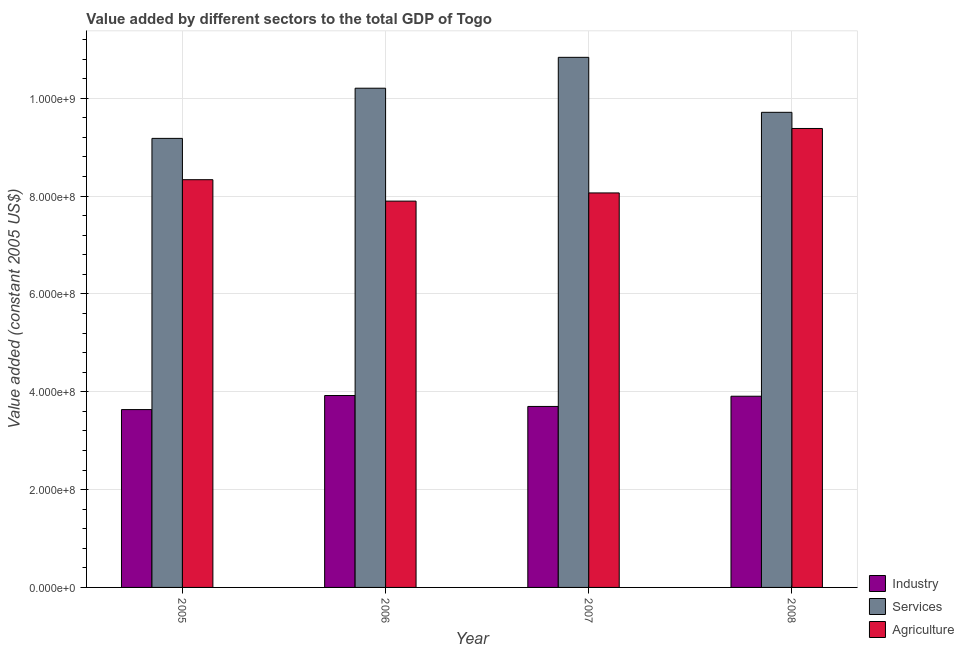How many groups of bars are there?
Offer a very short reply. 4. Are the number of bars on each tick of the X-axis equal?
Keep it short and to the point. Yes. How many bars are there on the 4th tick from the left?
Ensure brevity in your answer.  3. What is the label of the 2nd group of bars from the left?
Keep it short and to the point. 2006. What is the value added by agricultural sector in 2006?
Provide a short and direct response. 7.90e+08. Across all years, what is the maximum value added by agricultural sector?
Keep it short and to the point. 9.38e+08. Across all years, what is the minimum value added by services?
Make the answer very short. 9.18e+08. In which year was the value added by services minimum?
Ensure brevity in your answer.  2005. What is the total value added by services in the graph?
Your response must be concise. 3.99e+09. What is the difference between the value added by agricultural sector in 2005 and that in 2006?
Your answer should be very brief. 4.38e+07. What is the difference between the value added by agricultural sector in 2007 and the value added by industrial sector in 2006?
Your answer should be very brief. 1.67e+07. What is the average value added by agricultural sector per year?
Provide a succinct answer. 8.42e+08. In how many years, is the value added by services greater than 760000000 US$?
Keep it short and to the point. 4. What is the ratio of the value added by industrial sector in 2005 to that in 2007?
Your answer should be compact. 0.98. What is the difference between the highest and the second highest value added by services?
Offer a very short reply. 6.31e+07. What is the difference between the highest and the lowest value added by agricultural sector?
Make the answer very short. 1.49e+08. What does the 1st bar from the left in 2008 represents?
Offer a terse response. Industry. What does the 2nd bar from the right in 2006 represents?
Provide a short and direct response. Services. Is it the case that in every year, the sum of the value added by industrial sector and value added by services is greater than the value added by agricultural sector?
Make the answer very short. Yes. What is the difference between two consecutive major ticks on the Y-axis?
Your answer should be compact. 2.00e+08. Are the values on the major ticks of Y-axis written in scientific E-notation?
Offer a terse response. Yes. Where does the legend appear in the graph?
Ensure brevity in your answer.  Bottom right. What is the title of the graph?
Keep it short and to the point. Value added by different sectors to the total GDP of Togo. What is the label or title of the X-axis?
Offer a terse response. Year. What is the label or title of the Y-axis?
Give a very brief answer. Value added (constant 2005 US$). What is the Value added (constant 2005 US$) in Industry in 2005?
Make the answer very short. 3.64e+08. What is the Value added (constant 2005 US$) in Services in 2005?
Provide a short and direct response. 9.18e+08. What is the Value added (constant 2005 US$) of Agriculture in 2005?
Your answer should be very brief. 8.34e+08. What is the Value added (constant 2005 US$) in Industry in 2006?
Your answer should be compact. 3.92e+08. What is the Value added (constant 2005 US$) in Services in 2006?
Ensure brevity in your answer.  1.02e+09. What is the Value added (constant 2005 US$) in Agriculture in 2006?
Make the answer very short. 7.90e+08. What is the Value added (constant 2005 US$) in Industry in 2007?
Offer a very short reply. 3.70e+08. What is the Value added (constant 2005 US$) in Services in 2007?
Give a very brief answer. 1.08e+09. What is the Value added (constant 2005 US$) in Agriculture in 2007?
Keep it short and to the point. 8.06e+08. What is the Value added (constant 2005 US$) in Industry in 2008?
Make the answer very short. 3.91e+08. What is the Value added (constant 2005 US$) in Services in 2008?
Your response must be concise. 9.71e+08. What is the Value added (constant 2005 US$) in Agriculture in 2008?
Offer a terse response. 9.38e+08. Across all years, what is the maximum Value added (constant 2005 US$) of Industry?
Offer a very short reply. 3.92e+08. Across all years, what is the maximum Value added (constant 2005 US$) in Services?
Make the answer very short. 1.08e+09. Across all years, what is the maximum Value added (constant 2005 US$) in Agriculture?
Offer a very short reply. 9.38e+08. Across all years, what is the minimum Value added (constant 2005 US$) of Industry?
Ensure brevity in your answer.  3.64e+08. Across all years, what is the minimum Value added (constant 2005 US$) of Services?
Your response must be concise. 9.18e+08. Across all years, what is the minimum Value added (constant 2005 US$) in Agriculture?
Provide a succinct answer. 7.90e+08. What is the total Value added (constant 2005 US$) in Industry in the graph?
Keep it short and to the point. 1.52e+09. What is the total Value added (constant 2005 US$) in Services in the graph?
Make the answer very short. 3.99e+09. What is the total Value added (constant 2005 US$) of Agriculture in the graph?
Your response must be concise. 3.37e+09. What is the difference between the Value added (constant 2005 US$) of Industry in 2005 and that in 2006?
Give a very brief answer. -2.87e+07. What is the difference between the Value added (constant 2005 US$) in Services in 2005 and that in 2006?
Give a very brief answer. -1.03e+08. What is the difference between the Value added (constant 2005 US$) in Agriculture in 2005 and that in 2006?
Ensure brevity in your answer.  4.38e+07. What is the difference between the Value added (constant 2005 US$) in Industry in 2005 and that in 2007?
Your answer should be compact. -6.42e+06. What is the difference between the Value added (constant 2005 US$) in Services in 2005 and that in 2007?
Your response must be concise. -1.66e+08. What is the difference between the Value added (constant 2005 US$) of Agriculture in 2005 and that in 2007?
Offer a terse response. 2.71e+07. What is the difference between the Value added (constant 2005 US$) in Industry in 2005 and that in 2008?
Your answer should be compact. -2.73e+07. What is the difference between the Value added (constant 2005 US$) in Services in 2005 and that in 2008?
Your response must be concise. -5.33e+07. What is the difference between the Value added (constant 2005 US$) in Agriculture in 2005 and that in 2008?
Your answer should be very brief. -1.05e+08. What is the difference between the Value added (constant 2005 US$) of Industry in 2006 and that in 2007?
Your answer should be very brief. 2.23e+07. What is the difference between the Value added (constant 2005 US$) in Services in 2006 and that in 2007?
Your answer should be compact. -6.31e+07. What is the difference between the Value added (constant 2005 US$) of Agriculture in 2006 and that in 2007?
Give a very brief answer. -1.67e+07. What is the difference between the Value added (constant 2005 US$) of Industry in 2006 and that in 2008?
Offer a very short reply. 1.43e+06. What is the difference between the Value added (constant 2005 US$) in Services in 2006 and that in 2008?
Provide a succinct answer. 4.93e+07. What is the difference between the Value added (constant 2005 US$) in Agriculture in 2006 and that in 2008?
Your answer should be very brief. -1.49e+08. What is the difference between the Value added (constant 2005 US$) of Industry in 2007 and that in 2008?
Give a very brief answer. -2.09e+07. What is the difference between the Value added (constant 2005 US$) in Services in 2007 and that in 2008?
Keep it short and to the point. 1.12e+08. What is the difference between the Value added (constant 2005 US$) in Agriculture in 2007 and that in 2008?
Ensure brevity in your answer.  -1.32e+08. What is the difference between the Value added (constant 2005 US$) of Industry in 2005 and the Value added (constant 2005 US$) of Services in 2006?
Give a very brief answer. -6.57e+08. What is the difference between the Value added (constant 2005 US$) of Industry in 2005 and the Value added (constant 2005 US$) of Agriculture in 2006?
Keep it short and to the point. -4.26e+08. What is the difference between the Value added (constant 2005 US$) of Services in 2005 and the Value added (constant 2005 US$) of Agriculture in 2006?
Give a very brief answer. 1.28e+08. What is the difference between the Value added (constant 2005 US$) of Industry in 2005 and the Value added (constant 2005 US$) of Services in 2007?
Offer a terse response. -7.20e+08. What is the difference between the Value added (constant 2005 US$) in Industry in 2005 and the Value added (constant 2005 US$) in Agriculture in 2007?
Your answer should be very brief. -4.43e+08. What is the difference between the Value added (constant 2005 US$) in Services in 2005 and the Value added (constant 2005 US$) in Agriculture in 2007?
Ensure brevity in your answer.  1.12e+08. What is the difference between the Value added (constant 2005 US$) of Industry in 2005 and the Value added (constant 2005 US$) of Services in 2008?
Provide a succinct answer. -6.08e+08. What is the difference between the Value added (constant 2005 US$) of Industry in 2005 and the Value added (constant 2005 US$) of Agriculture in 2008?
Provide a short and direct response. -5.75e+08. What is the difference between the Value added (constant 2005 US$) in Services in 2005 and the Value added (constant 2005 US$) in Agriculture in 2008?
Give a very brief answer. -2.02e+07. What is the difference between the Value added (constant 2005 US$) in Industry in 2006 and the Value added (constant 2005 US$) in Services in 2007?
Make the answer very short. -6.91e+08. What is the difference between the Value added (constant 2005 US$) in Industry in 2006 and the Value added (constant 2005 US$) in Agriculture in 2007?
Ensure brevity in your answer.  -4.14e+08. What is the difference between the Value added (constant 2005 US$) of Services in 2006 and the Value added (constant 2005 US$) of Agriculture in 2007?
Your response must be concise. 2.14e+08. What is the difference between the Value added (constant 2005 US$) of Industry in 2006 and the Value added (constant 2005 US$) of Services in 2008?
Offer a terse response. -5.79e+08. What is the difference between the Value added (constant 2005 US$) of Industry in 2006 and the Value added (constant 2005 US$) of Agriculture in 2008?
Ensure brevity in your answer.  -5.46e+08. What is the difference between the Value added (constant 2005 US$) in Services in 2006 and the Value added (constant 2005 US$) in Agriculture in 2008?
Ensure brevity in your answer.  8.23e+07. What is the difference between the Value added (constant 2005 US$) in Industry in 2007 and the Value added (constant 2005 US$) in Services in 2008?
Ensure brevity in your answer.  -6.01e+08. What is the difference between the Value added (constant 2005 US$) in Industry in 2007 and the Value added (constant 2005 US$) in Agriculture in 2008?
Give a very brief answer. -5.68e+08. What is the difference between the Value added (constant 2005 US$) in Services in 2007 and the Value added (constant 2005 US$) in Agriculture in 2008?
Offer a terse response. 1.45e+08. What is the average Value added (constant 2005 US$) of Industry per year?
Provide a succinct answer. 3.79e+08. What is the average Value added (constant 2005 US$) in Services per year?
Provide a short and direct response. 9.98e+08. What is the average Value added (constant 2005 US$) of Agriculture per year?
Your response must be concise. 8.42e+08. In the year 2005, what is the difference between the Value added (constant 2005 US$) of Industry and Value added (constant 2005 US$) of Services?
Your response must be concise. -5.54e+08. In the year 2005, what is the difference between the Value added (constant 2005 US$) of Industry and Value added (constant 2005 US$) of Agriculture?
Your answer should be very brief. -4.70e+08. In the year 2005, what is the difference between the Value added (constant 2005 US$) of Services and Value added (constant 2005 US$) of Agriculture?
Make the answer very short. 8.45e+07. In the year 2006, what is the difference between the Value added (constant 2005 US$) in Industry and Value added (constant 2005 US$) in Services?
Ensure brevity in your answer.  -6.28e+08. In the year 2006, what is the difference between the Value added (constant 2005 US$) of Industry and Value added (constant 2005 US$) of Agriculture?
Provide a short and direct response. -3.97e+08. In the year 2006, what is the difference between the Value added (constant 2005 US$) of Services and Value added (constant 2005 US$) of Agriculture?
Offer a terse response. 2.31e+08. In the year 2007, what is the difference between the Value added (constant 2005 US$) in Industry and Value added (constant 2005 US$) in Services?
Offer a terse response. -7.14e+08. In the year 2007, what is the difference between the Value added (constant 2005 US$) in Industry and Value added (constant 2005 US$) in Agriculture?
Your response must be concise. -4.36e+08. In the year 2007, what is the difference between the Value added (constant 2005 US$) in Services and Value added (constant 2005 US$) in Agriculture?
Give a very brief answer. 2.77e+08. In the year 2008, what is the difference between the Value added (constant 2005 US$) of Industry and Value added (constant 2005 US$) of Services?
Offer a very short reply. -5.80e+08. In the year 2008, what is the difference between the Value added (constant 2005 US$) in Industry and Value added (constant 2005 US$) in Agriculture?
Your response must be concise. -5.47e+08. In the year 2008, what is the difference between the Value added (constant 2005 US$) in Services and Value added (constant 2005 US$) in Agriculture?
Your answer should be compact. 3.30e+07. What is the ratio of the Value added (constant 2005 US$) of Industry in 2005 to that in 2006?
Provide a succinct answer. 0.93. What is the ratio of the Value added (constant 2005 US$) of Services in 2005 to that in 2006?
Ensure brevity in your answer.  0.9. What is the ratio of the Value added (constant 2005 US$) in Agriculture in 2005 to that in 2006?
Provide a short and direct response. 1.06. What is the ratio of the Value added (constant 2005 US$) in Industry in 2005 to that in 2007?
Provide a succinct answer. 0.98. What is the ratio of the Value added (constant 2005 US$) in Services in 2005 to that in 2007?
Ensure brevity in your answer.  0.85. What is the ratio of the Value added (constant 2005 US$) of Agriculture in 2005 to that in 2007?
Make the answer very short. 1.03. What is the ratio of the Value added (constant 2005 US$) in Industry in 2005 to that in 2008?
Provide a succinct answer. 0.93. What is the ratio of the Value added (constant 2005 US$) of Services in 2005 to that in 2008?
Your answer should be very brief. 0.95. What is the ratio of the Value added (constant 2005 US$) in Agriculture in 2005 to that in 2008?
Your response must be concise. 0.89. What is the ratio of the Value added (constant 2005 US$) of Industry in 2006 to that in 2007?
Make the answer very short. 1.06. What is the ratio of the Value added (constant 2005 US$) of Services in 2006 to that in 2007?
Your response must be concise. 0.94. What is the ratio of the Value added (constant 2005 US$) in Agriculture in 2006 to that in 2007?
Your answer should be compact. 0.98. What is the ratio of the Value added (constant 2005 US$) of Industry in 2006 to that in 2008?
Keep it short and to the point. 1. What is the ratio of the Value added (constant 2005 US$) of Services in 2006 to that in 2008?
Provide a short and direct response. 1.05. What is the ratio of the Value added (constant 2005 US$) in Agriculture in 2006 to that in 2008?
Offer a terse response. 0.84. What is the ratio of the Value added (constant 2005 US$) in Industry in 2007 to that in 2008?
Your response must be concise. 0.95. What is the ratio of the Value added (constant 2005 US$) of Services in 2007 to that in 2008?
Your answer should be very brief. 1.12. What is the ratio of the Value added (constant 2005 US$) in Agriculture in 2007 to that in 2008?
Ensure brevity in your answer.  0.86. What is the difference between the highest and the second highest Value added (constant 2005 US$) in Industry?
Ensure brevity in your answer.  1.43e+06. What is the difference between the highest and the second highest Value added (constant 2005 US$) in Services?
Offer a very short reply. 6.31e+07. What is the difference between the highest and the second highest Value added (constant 2005 US$) of Agriculture?
Offer a very short reply. 1.05e+08. What is the difference between the highest and the lowest Value added (constant 2005 US$) in Industry?
Make the answer very short. 2.87e+07. What is the difference between the highest and the lowest Value added (constant 2005 US$) in Services?
Give a very brief answer. 1.66e+08. What is the difference between the highest and the lowest Value added (constant 2005 US$) of Agriculture?
Ensure brevity in your answer.  1.49e+08. 